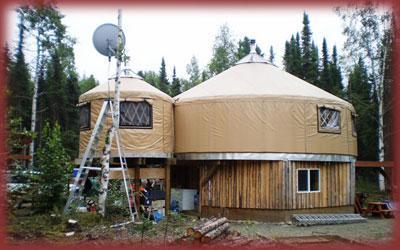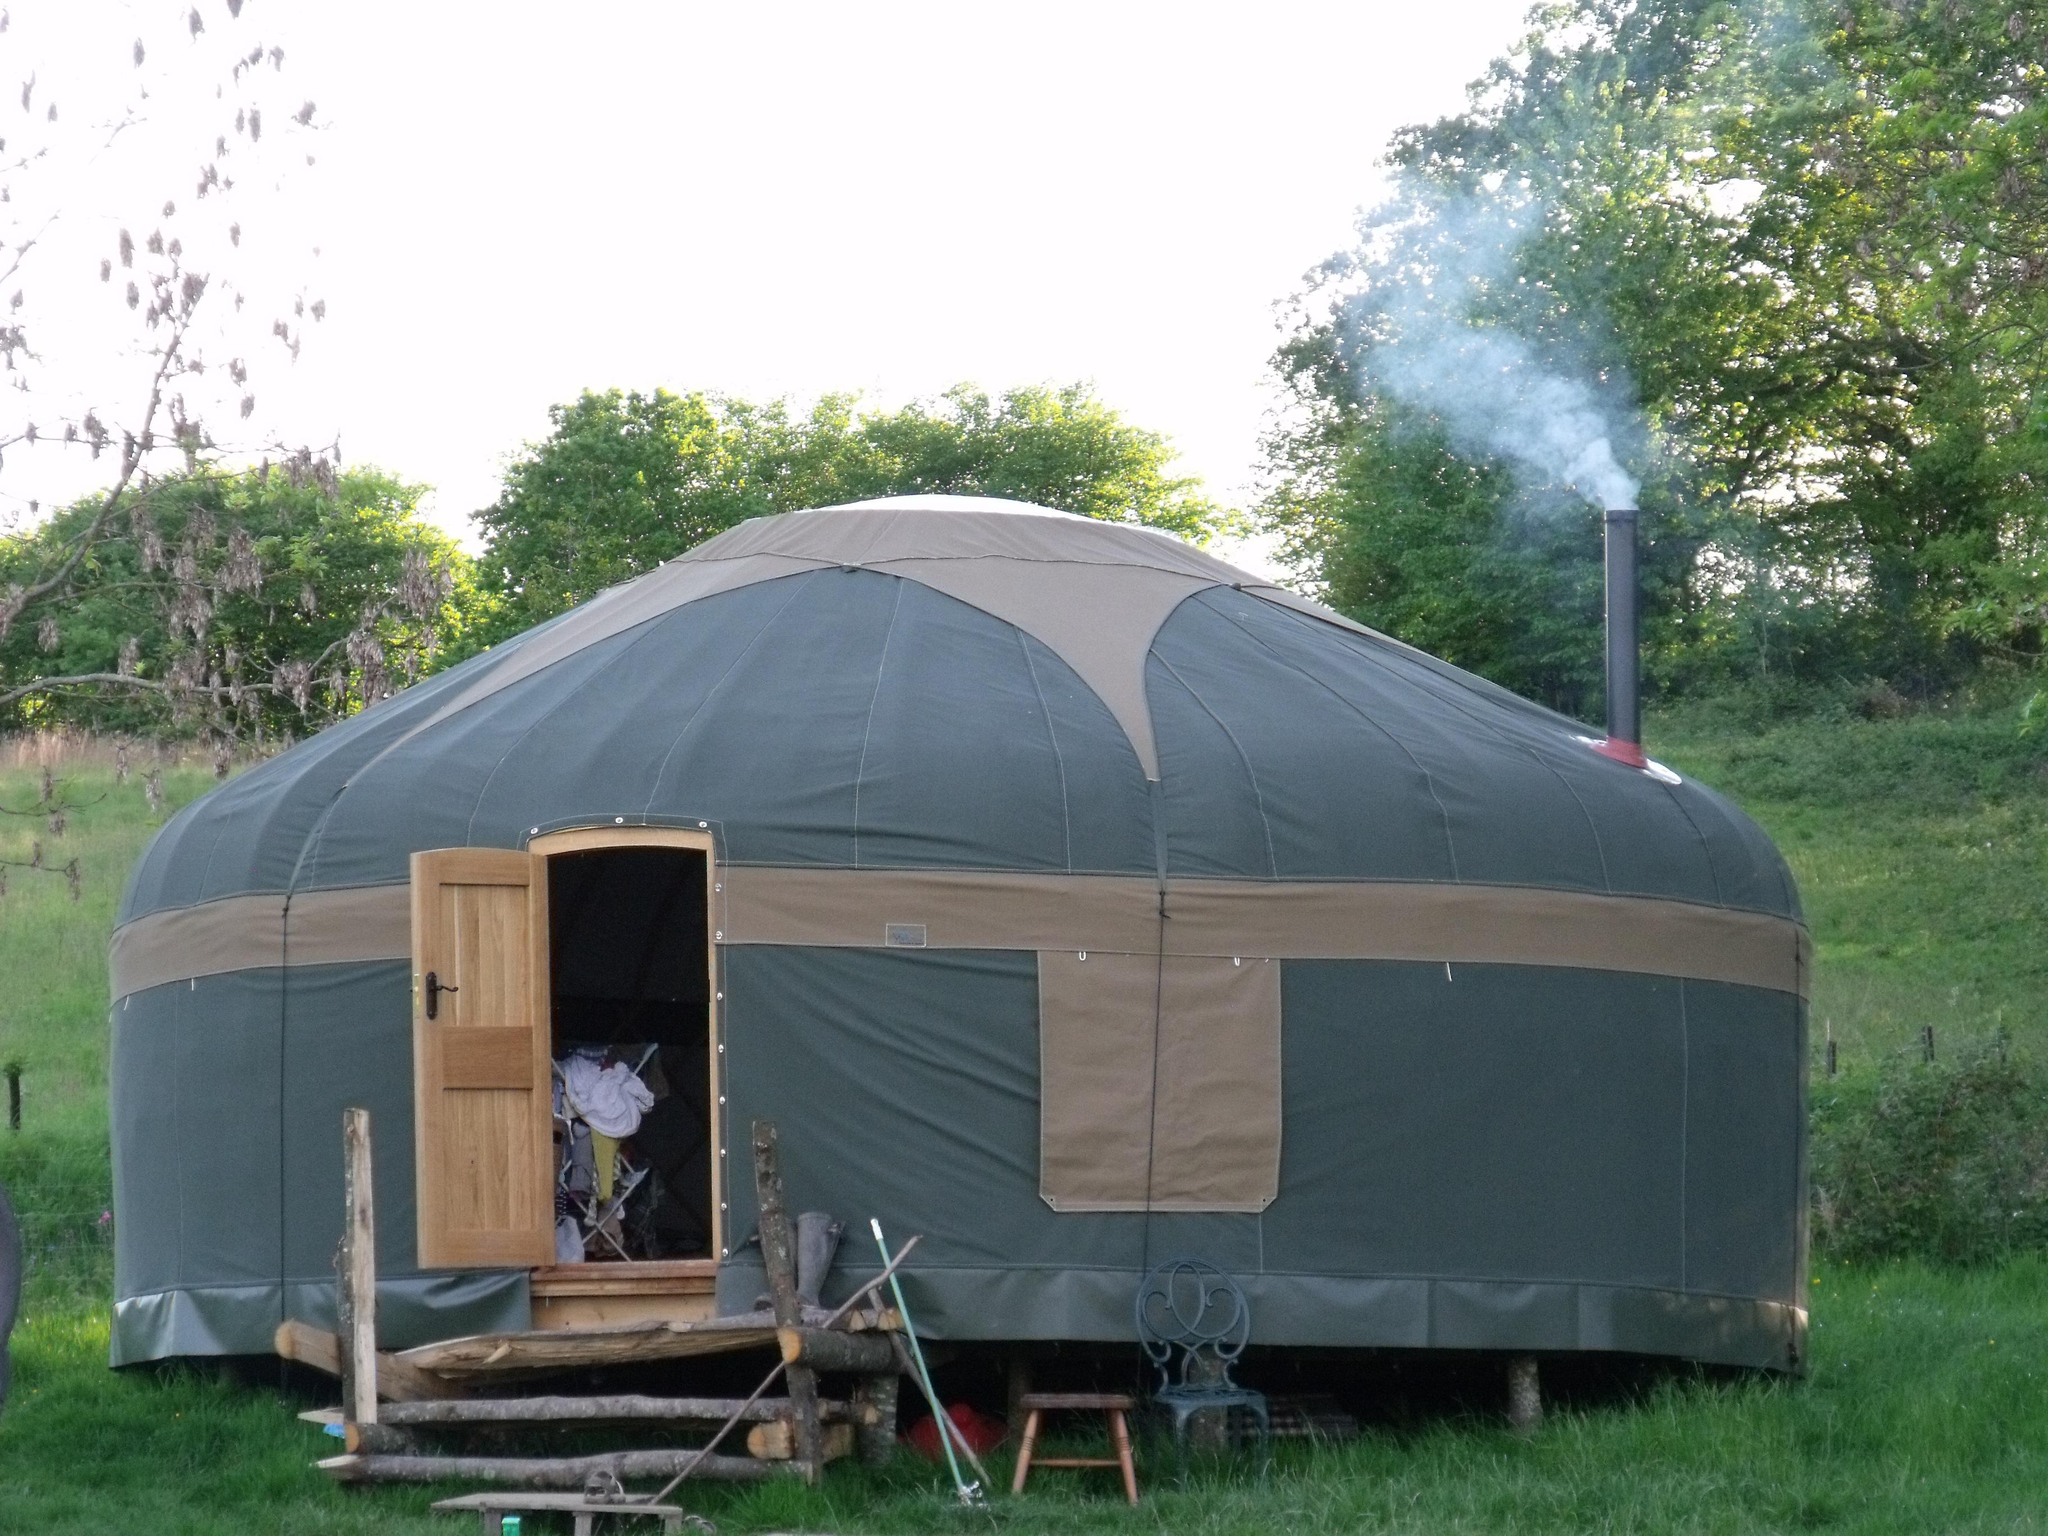The first image is the image on the left, the second image is the image on the right. Evaluate the accuracy of this statement regarding the images: "One of the images contains a cottage with smoke coming out of its chimney.". Is it true? Answer yes or no. Yes. The first image is the image on the left, the second image is the image on the right. Analyze the images presented: Is the assertion "Smoke is coming out of the chimney at the right side of a round building." valid? Answer yes or no. Yes. 